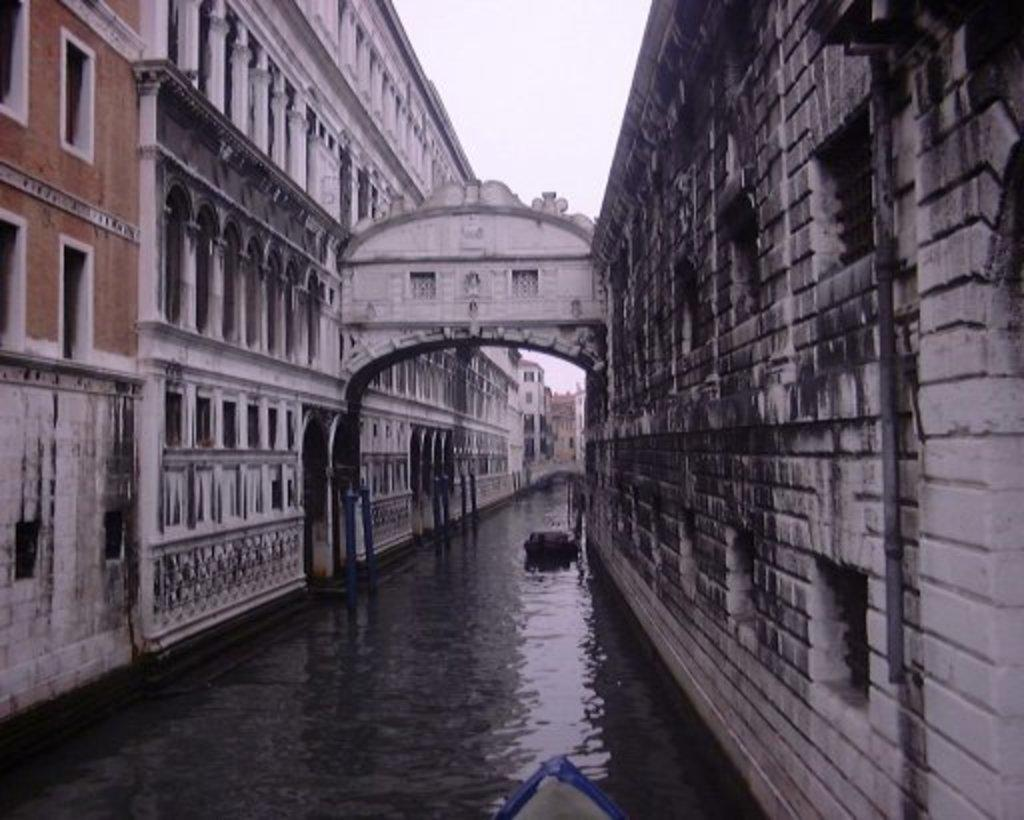What type of water feature is present in the image? There is a canal in the image. What structures are located near the canal? There are buildings on either side of the canal. What can be seen in the background of the image? The sky is visible in the background of the image. What type of curtain can be seen hanging from the queen's window in the image? There is no queen or window present in the image, and therefore no curtain can be seen. 